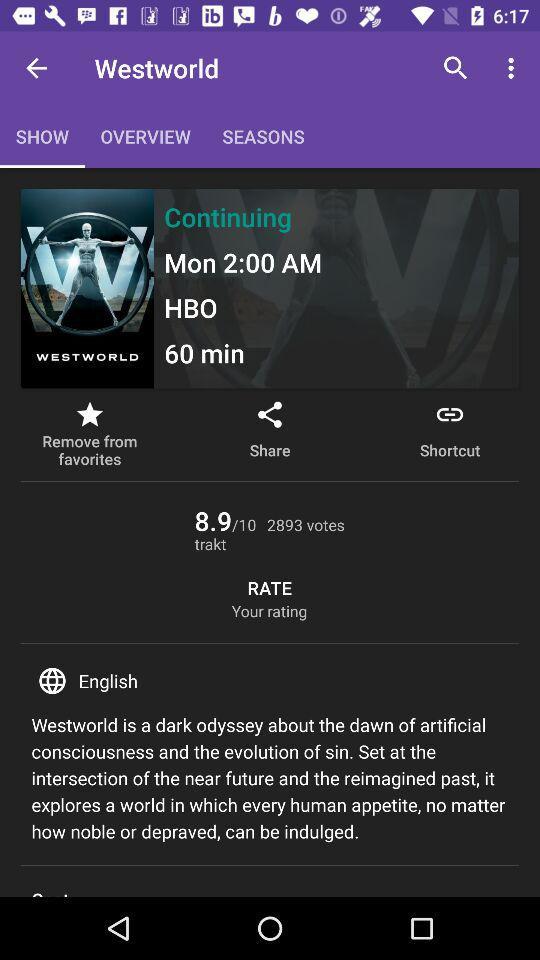What is the duration of the show? The duration of the show is 60 minutes. 